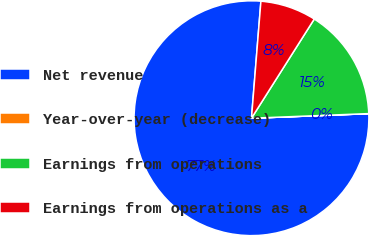Convert chart to OTSL. <chart><loc_0><loc_0><loc_500><loc_500><pie_chart><fcel>Net revenue<fcel>Year-over-year (decrease)<fcel>Earnings from operations<fcel>Earnings from operations as a<nl><fcel>76.9%<fcel>0.01%<fcel>15.39%<fcel>7.7%<nl></chart> 